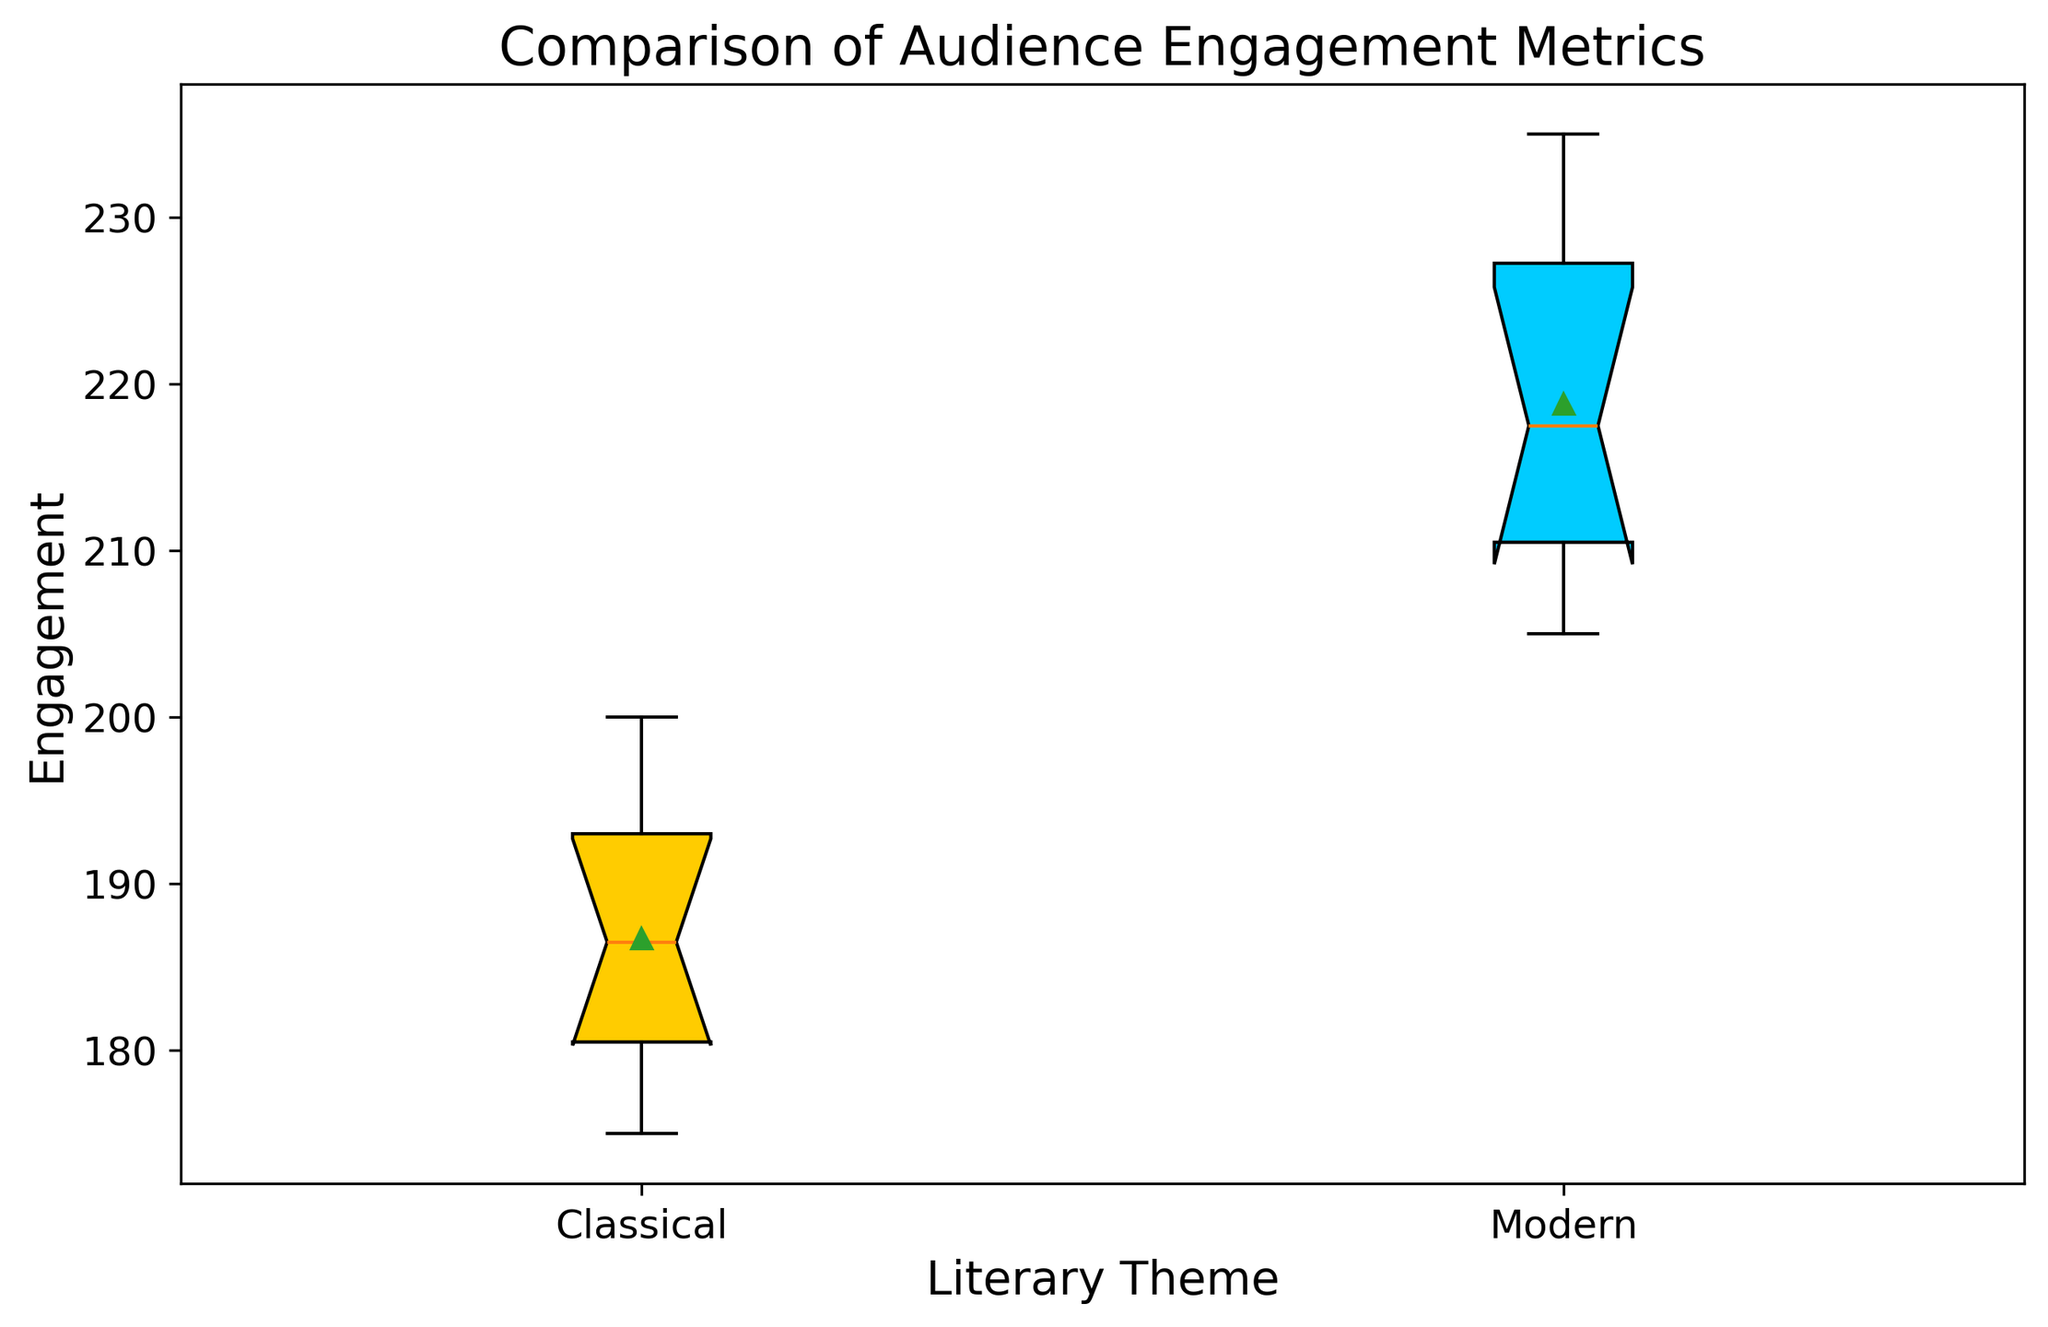What is the median engagement for the Classical theme? The middle value of the Classical theme data is calculated by first ordering the engagement figures and finding the middle number. For the Classical theme: [175, 178, 180, 182, 185, 188, 190, 194, 195, 200]. The median is the average of the 5th and 6th values: (185+188)/2 = 186.5
Answer: 186.5 Which theme shows a higher range of audience engagement? Range is calculated as the difference between the maximum and minimum values. For the Classical theme, the range is 200 - 175 = 25. For the Modern theme, the range is 235 - 205 = 30. Comparing these, Modern has a higher range.
Answer: Modern How do the mean values of engagement compare between Classical and Modern themes? The mean is calculated as the total sum of the values divided by the number of values. For Classical: (180 + 190 + 175 + 200 + 185 + 195 + 178 + 182 + 188 + 194)/10 = 1867/10 = 186.7. For Modern: (220 + 210 + 230 + 205 + 225 + 215 + 235 + 208 + 212 + 228)/10 = 2188/10 = 218.8. Modern has a higher mean.
Answer: Modern Which theme has a higher third quartile (Q3) value, and what is it? Q3 is the median of the upper half of the data. Classical data upper half: [185, 188, 190, 194, 195, 200]. Q3 = 194.5. Modern data upper half: [215, 220, 225, 228, 230, 235]. Q3 = 229.5. Modern has the higher Q3 value.
Answer: Modern, 229.5 What are the mean values represented on the box plot for each theme? The mean values are shown as green triangles on the box plot. They represent the mean engagement values. For Classical, it is around 186.7, and for Modern, it is around 218.8.
Answer: Classical: ~186.7, Modern: ~218.8 Which theme has a broader interquartile range (IQR)? IQR is calculated as Q3 - Q1. For Classical: Q3 is 194.5, Q1 data lower half: (180 + 182) / 2 = 181. Q1 = 181, so IQR = 194.5 - 181 = 13.5. For Modern: Q3 is 229.5, Q1 data lower half: (210 + 212) / 2 = 211. So Q1 = 211, IQR = 229.5 - 211 = 18.5. Modern has a broader IQR.
Answer: Modern Are there any outliers visible on the box plot for either theme? Outliers are typically displayed as points lying beyond the whiskers of the box plot. In this figure, no data points lie outside the whiskers for either theme, suggesting there are no outliers.
Answer: No 